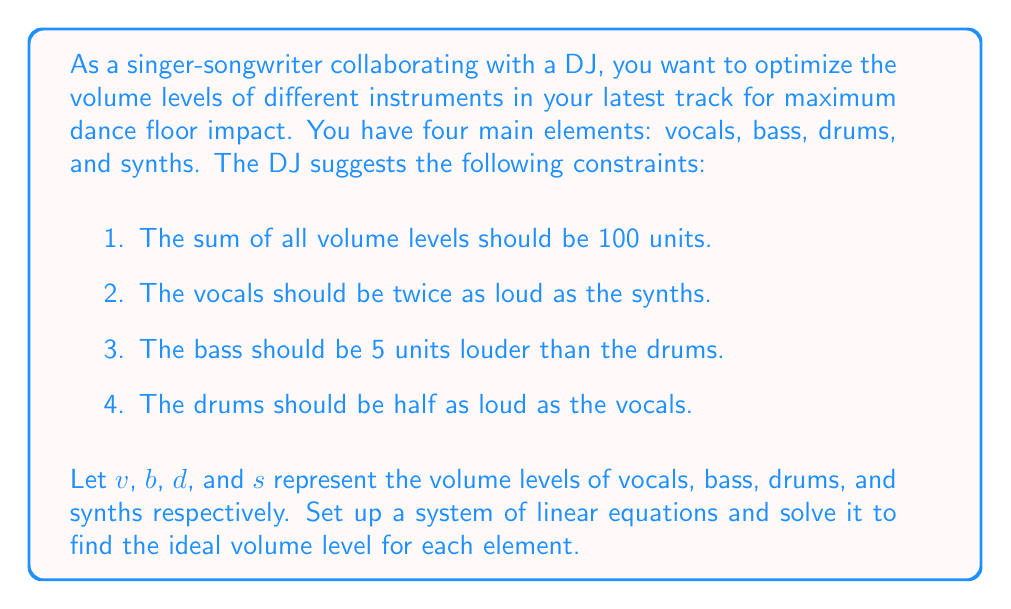Solve this math problem. Let's approach this step-by-step:

1) First, we'll set up our system of linear equations based on the given constraints:

   $$\begin{cases}
   v + b + d + s = 100 & \text{(sum of volumes)}\\
   v = 2s & \text{(vocals twice as loud as synths)}\\
   b = d + 5 & \text{(bass 5 units louder than drums)}\\
   d = \frac{1}{2}v & \text{(drums half as loud as vocals)}
   \end{cases}$$

2) We can simplify this system by substituting equations into each other:
   
   From the third equation: $b = d + 5$
   From the fourth equation: $d = \frac{1}{2}v$
   
   Substituting these into the first equation:
   
   $$v + (d + 5) + d + \frac{1}{2}v = 100$$
   
   $$v + 2d + 5 + \frac{1}{2}v = 100$$
   
   $$\frac{3}{2}v + 2d = 95$$

3) Now we have two equations with two unknowns:

   $$\begin{cases}
   \frac{3}{2}v + 2d = 95\\
   d = \frac{1}{2}v
   \end{cases}$$

4) Substitute $d = \frac{1}{2}v$ into the first equation:

   $$\frac{3}{2}v + 2(\frac{1}{2}v) = 95$$
   
   $$\frac{3}{2}v + v = 95$$
   
   $$\frac{5}{2}v = 95$$
   
   $$v = 38$$

5) Now we can find the other values:

   $d = \frac{1}{2}v = \frac{1}{2}(38) = 19$
   
   $b = d + 5 = 19 + 5 = 24$
   
   $s = \frac{1}{2}v = \frac{1}{2}(38) = 19$

6) We can verify that these values satisfy all conditions:
   
   $38 + 24 + 19 + 19 = 100$ (sum is 100)
   
   $38 = 2(19)$ (vocals twice as loud as synths)
   
   $24 = 19 + 5$ (bass 5 units louder than drums)
   
   $19 = \frac{1}{2}(38)$ (drums half as loud as vocals)
Answer: The ideal volume levels are:
Vocals (v): 38 units
Bass (b): 24 units
Drums (d): 19 units
Synths (s): 19 units 